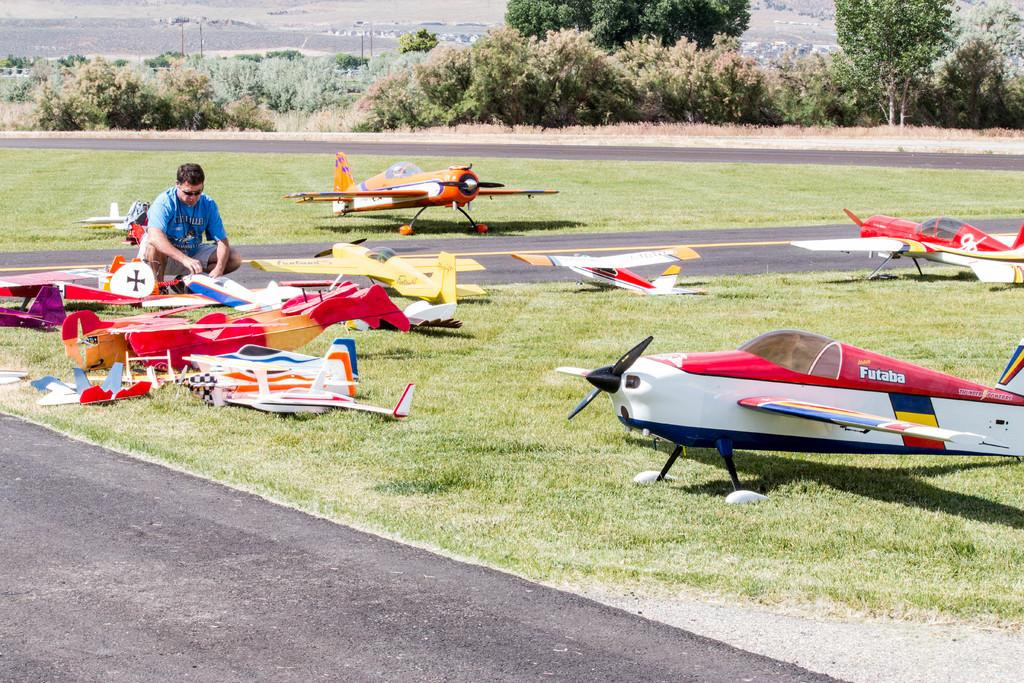<image>
Write a terse but informative summary of the picture. A Futaba plane sits in the grass with several other miniature planes. 